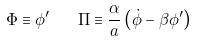Convert formula to latex. <formula><loc_0><loc_0><loc_500><loc_500>\Phi \equiv \phi ^ { \prime } \quad \Pi \equiv \frac { \alpha } { a } \left ( \dot { \phi } - \beta \phi ^ { \prime } \right )</formula> 